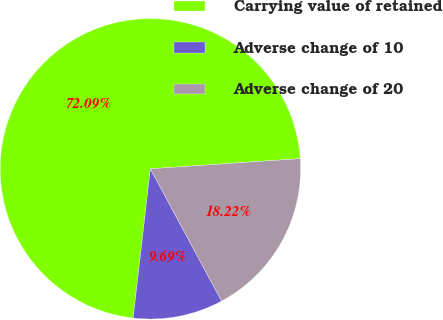Convert chart. <chart><loc_0><loc_0><loc_500><loc_500><pie_chart><fcel>Carrying value of retained<fcel>Adverse change of 10<fcel>Adverse change of 20<nl><fcel>72.09%<fcel>9.69%<fcel>18.22%<nl></chart> 